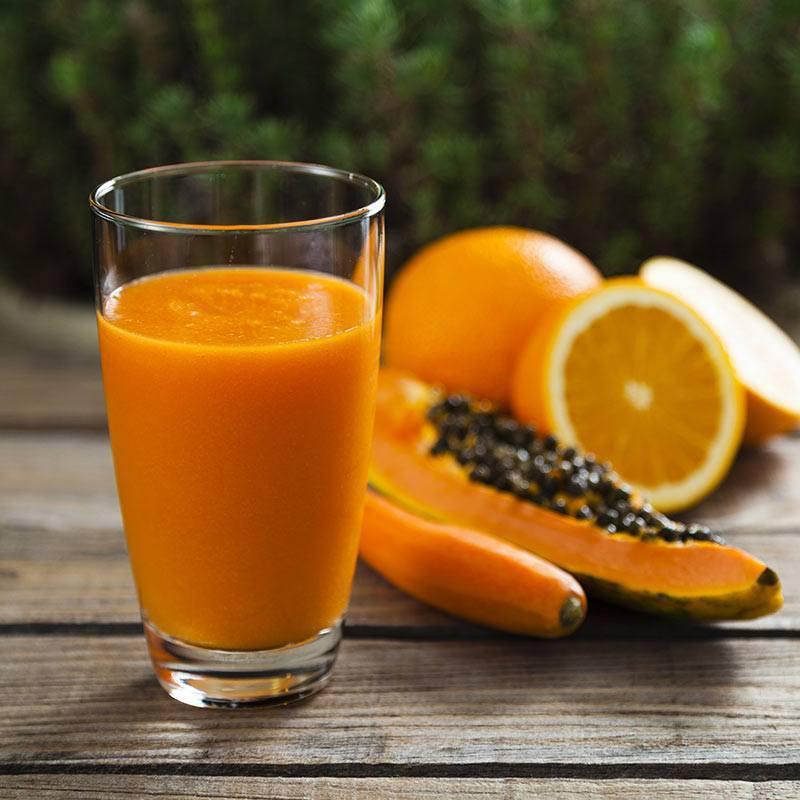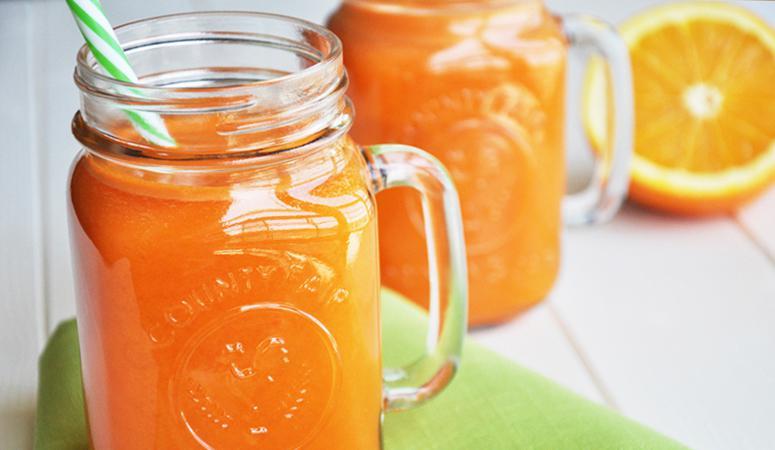The first image is the image on the left, the second image is the image on the right. Given the left and right images, does the statement "An image shows a striped straw in a jar-type beverage glass." hold true? Answer yes or no. Yes. The first image is the image on the left, the second image is the image on the right. Given the left and right images, does the statement "In one image, drinks are served in two mason jar glasses, one of them sitting on a cloth napkin, with striped straws." hold true? Answer yes or no. Yes. 